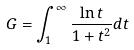Convert formula to latex. <formula><loc_0><loc_0><loc_500><loc_500>G = \int _ { 1 } ^ { \infty } \frac { \ln t } { 1 + t ^ { 2 } } d t</formula> 